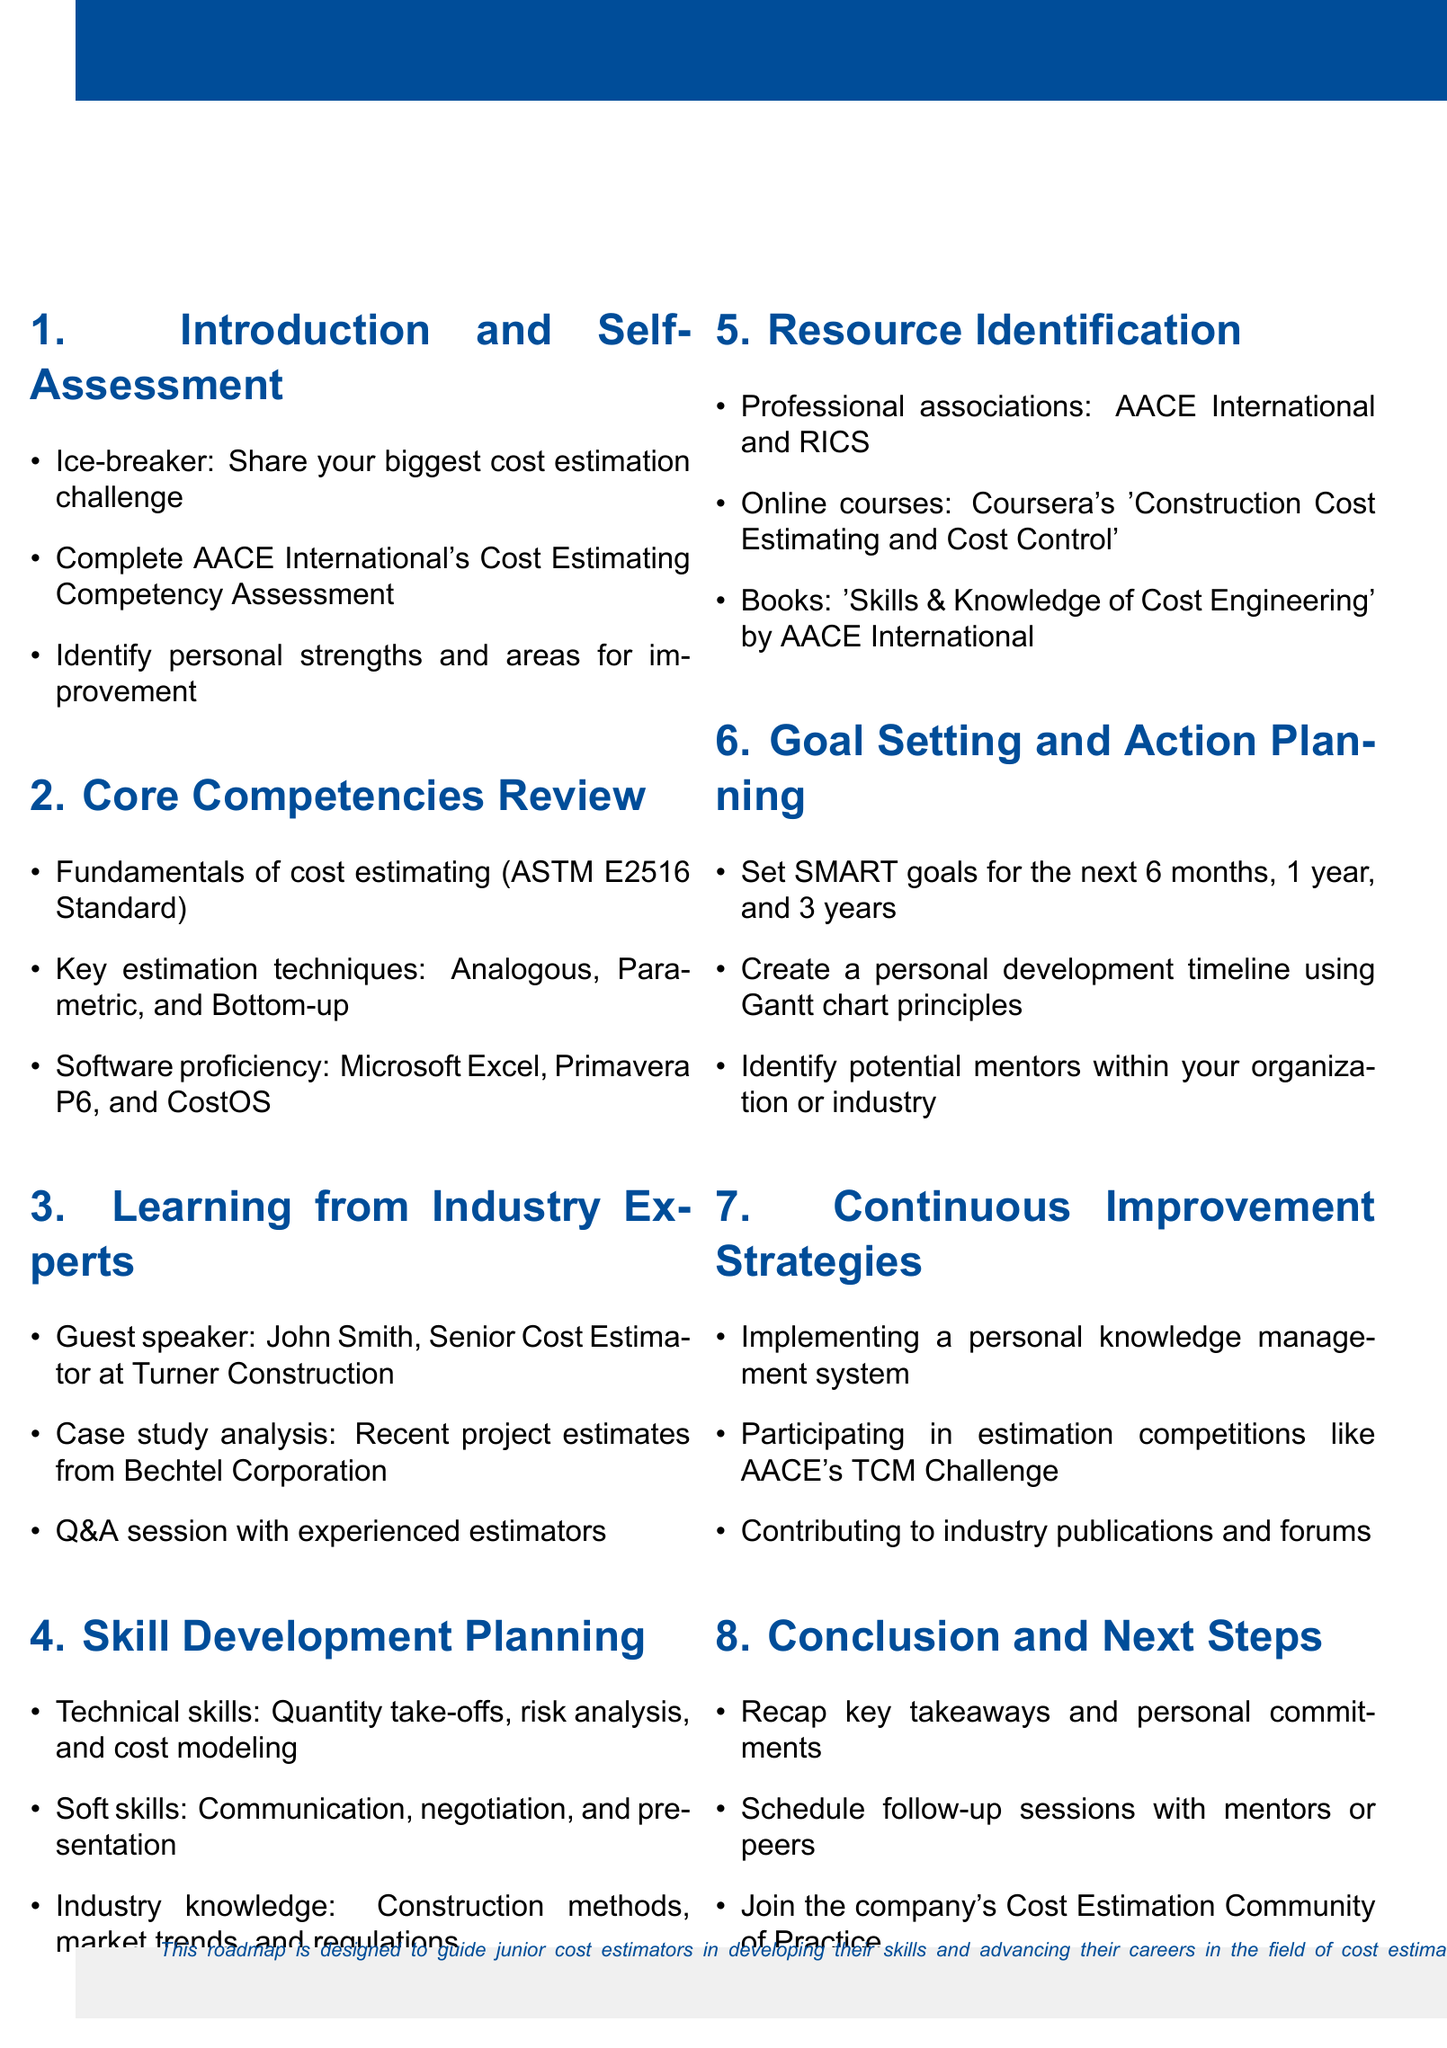What is the session title? The session title is clearly stated at the beginning of the document, which is "Developing a Personal Cost Estimation Skills Improvement Roadmap".
Answer: Developing a Personal Cost Estimation Skills Improvement Roadmap Who is the target audience? The document specifies the target audience for the session, which is "Junior cost estimators".
Answer: Junior cost estimators How long is the session? The duration of the session is mentioned, stating it will last for "4 hours".
Answer: 4 hours What is one key estimation technique discussed? The agenda lists several key estimation techniques under the "Core Competencies Review" section, including "Analogous".
Answer: Analogous Name one resource identified in the document. The "Resource Identification" section outlines various resources, one being "AACE International".
Answer: AACE International What is one focus area for skill development? The document specifies focus areas under the "Skill Development Planning" section, such as "Technical skills".
Answer: Technical skills What is scheduled at the conclusion of the session? The agenda highlights activities at the end of the session, specifically mentioning "Schedule follow-up sessions with mentors or peers".
Answer: Schedule follow-up sessions with mentors or peers What personal planning tool is suggested? The "Goal Setting and Action Planning" section recommends utilizing "Gantt chart principles" as a planning tool.
Answer: Gantt chart principles What type of strategies are discussed for continuous improvement? The document mentions "Continuous Improvement Strategies", which include various approaches like "Implementing a personal knowledge management system".
Answer: Implementing a personal knowledge management system 